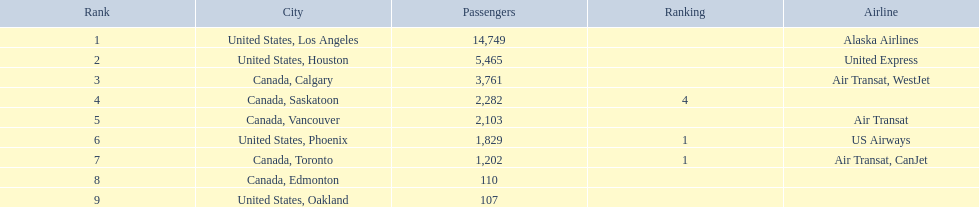Which figures can be found in the passengers column? 14,749, 5,465, 3,761, 2,282, 2,103, 1,829, 1,202, 110, 107. Which figure is the minimum in this column? 107. What is the related city for this minimum figure? United States, Oakland. 